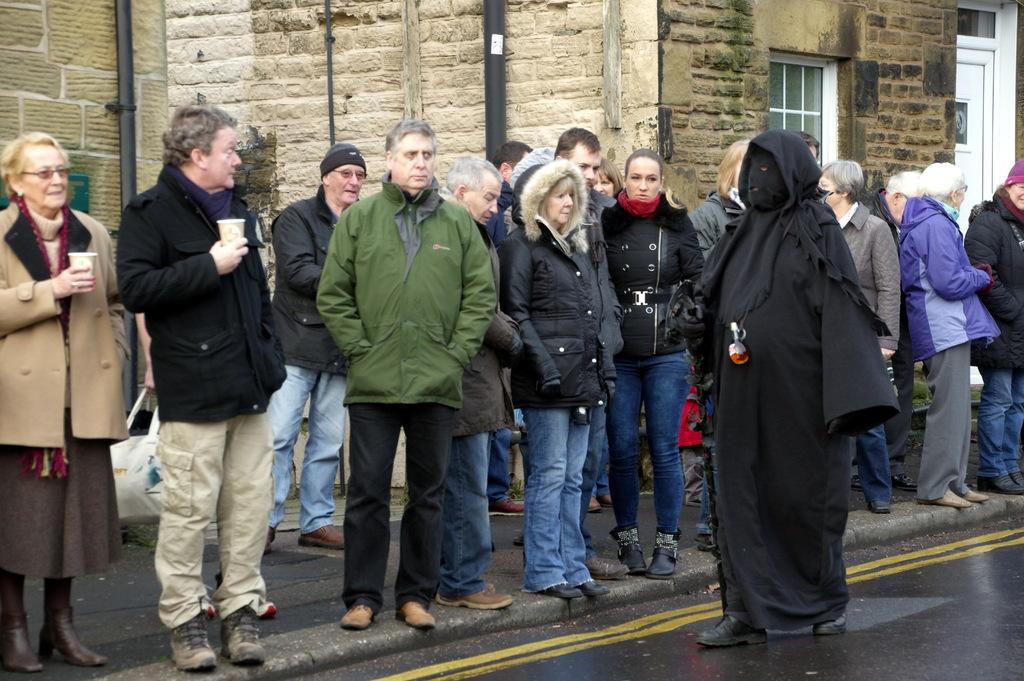Who or what can be seen in the image? There are people in the image. What is the primary feature of the landscape in the image? There is a road in the image. What can be seen in the distance in the image? There is a building, poles, a window, and a door in the background of the image. What type of seat can be seen on the people in the image? There are no seats visible on the people in the image. Can you describe the zipper on the sack in the image? There is no sack or zipper present in the image. 